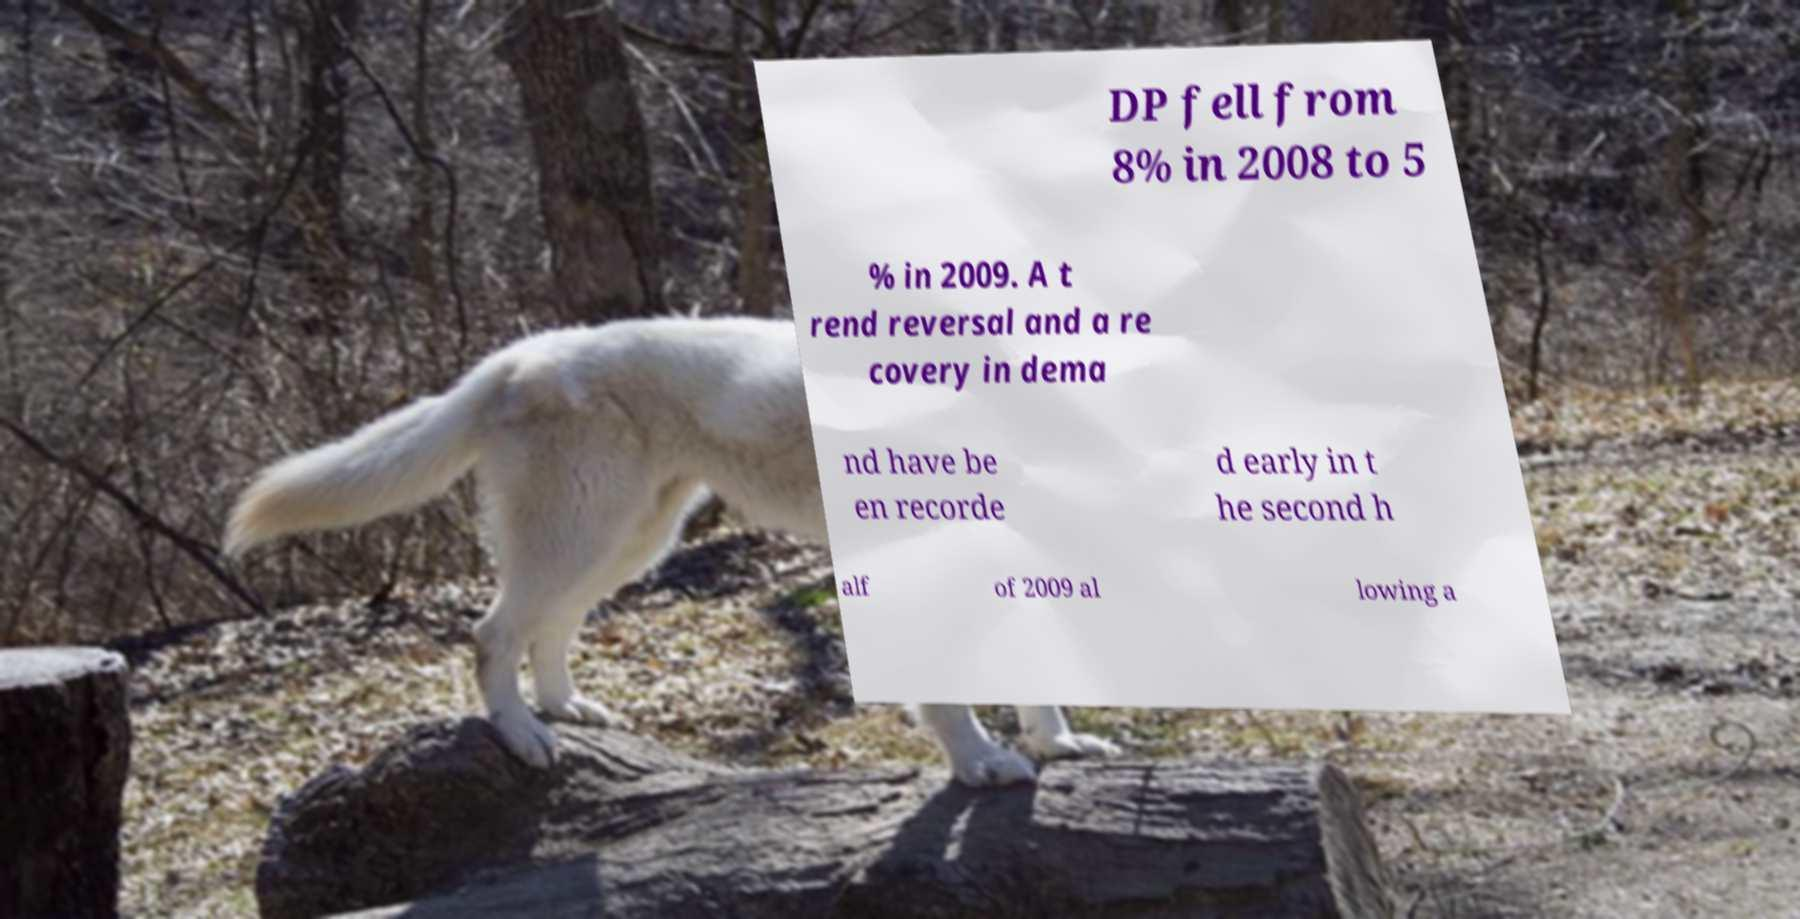Can you read and provide the text displayed in the image?This photo seems to have some interesting text. Can you extract and type it out for me? DP fell from 8% in 2008 to 5 % in 2009. A t rend reversal and a re covery in dema nd have be en recorde d early in t he second h alf of 2009 al lowing a 